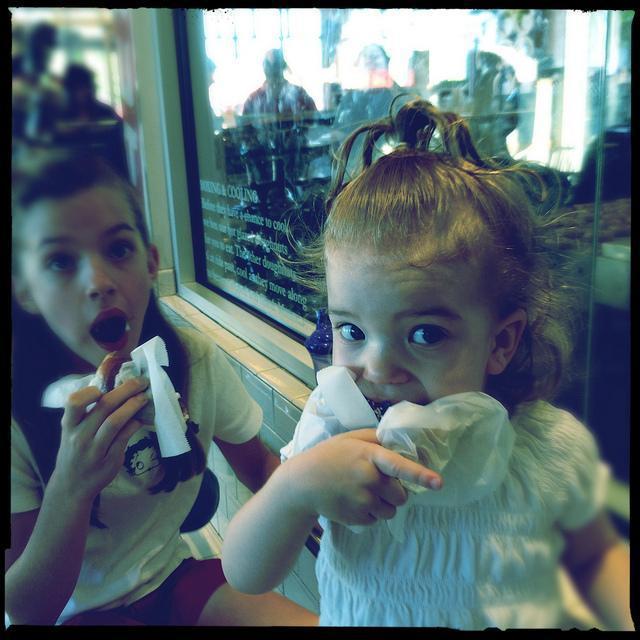How many people are in the picture?
Give a very brief answer. 5. 